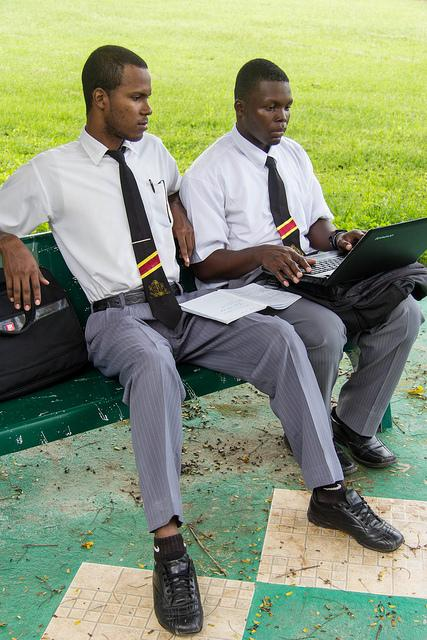What do the men's uniforms typically represent?

Choices:
A) sports
B) school
C) graduation
D) work school 